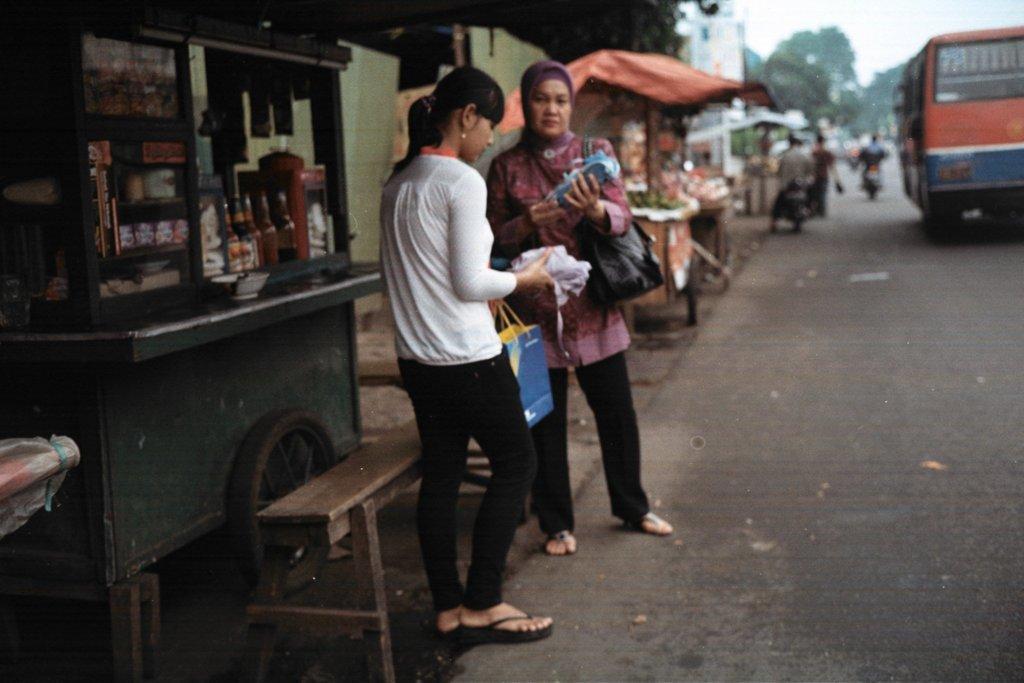How would you summarize this image in a sentence or two? In this image there are two persons standing on the road and at the left side of the image there is a shop and at the right side of the image there is a bus and two motorcycles. 